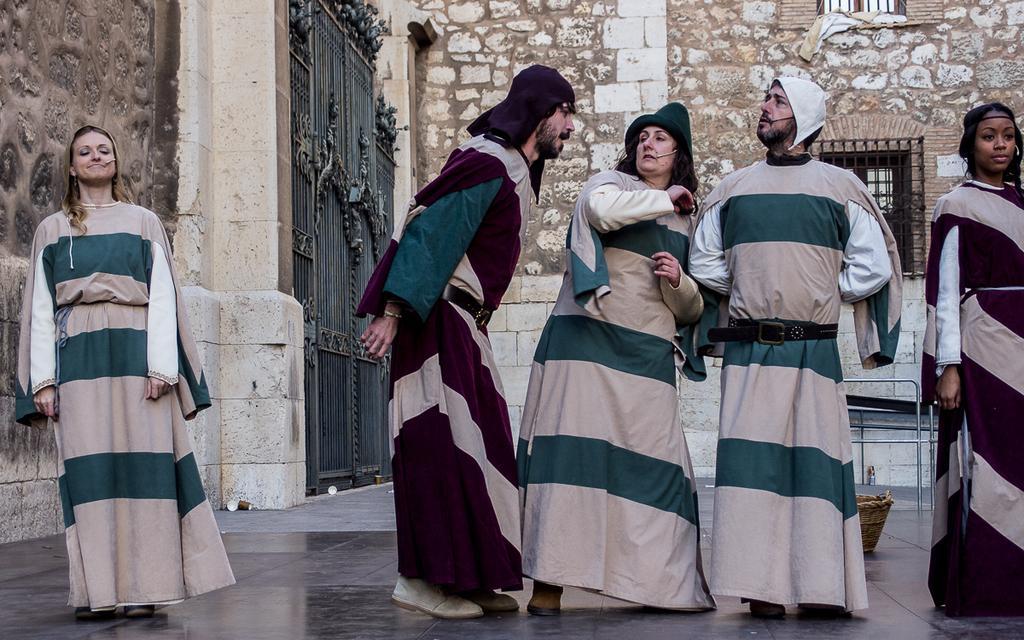Describe this image in one or two sentences. In this image there are five persons standing , and at the background there is a basket on the floor, iron rods, gates, building. 